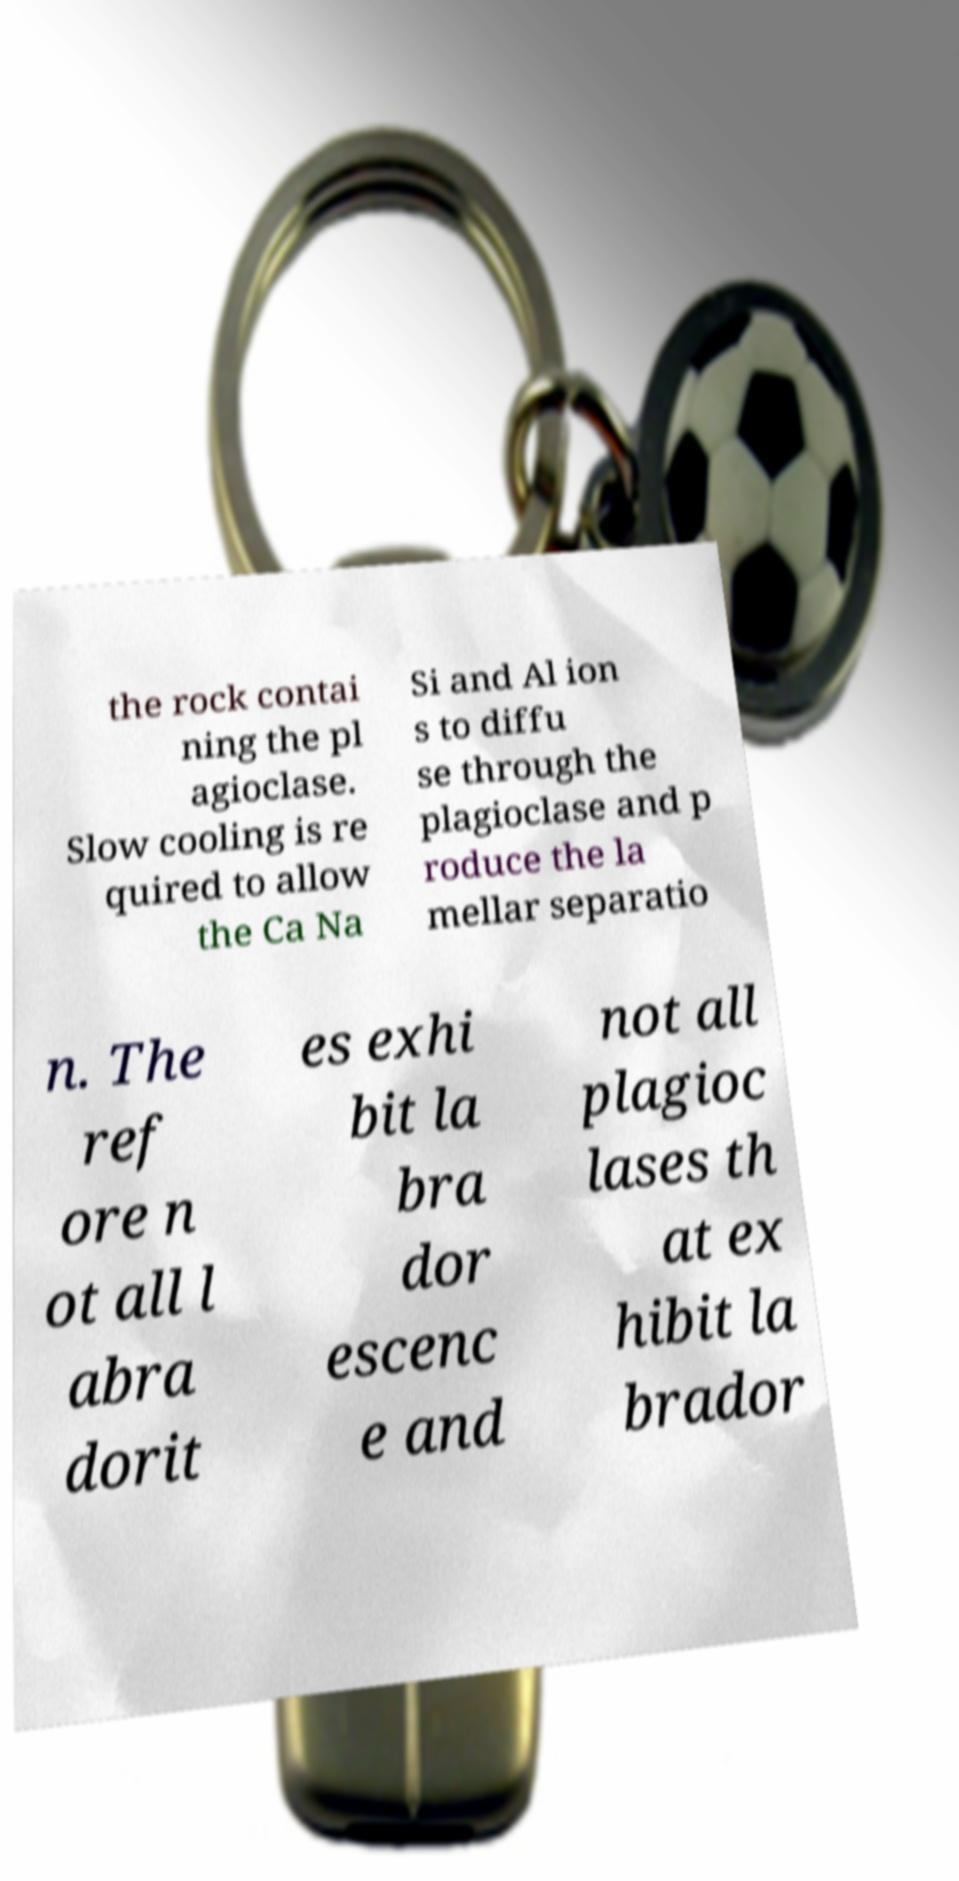Please identify and transcribe the text found in this image. the rock contai ning the pl agioclase. Slow cooling is re quired to allow the Ca Na Si and Al ion s to diffu se through the plagioclase and p roduce the la mellar separatio n. The ref ore n ot all l abra dorit es exhi bit la bra dor escenc e and not all plagioc lases th at ex hibit la brador 